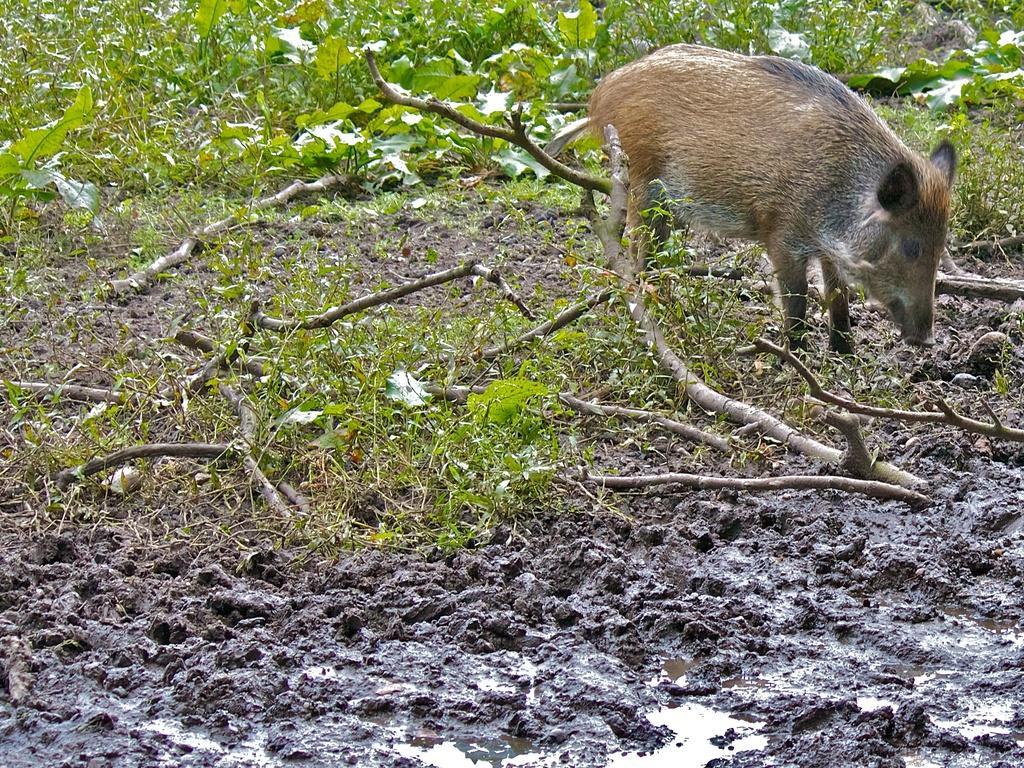Please provide a concise description of this image. In this image there is a pig standing on the land having few plants and wooden trunks are on it. 